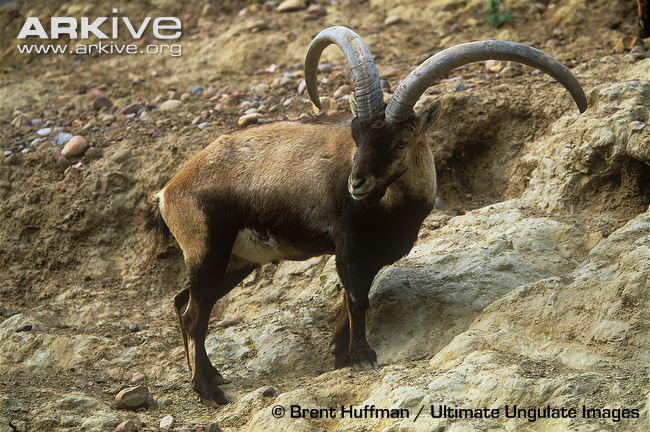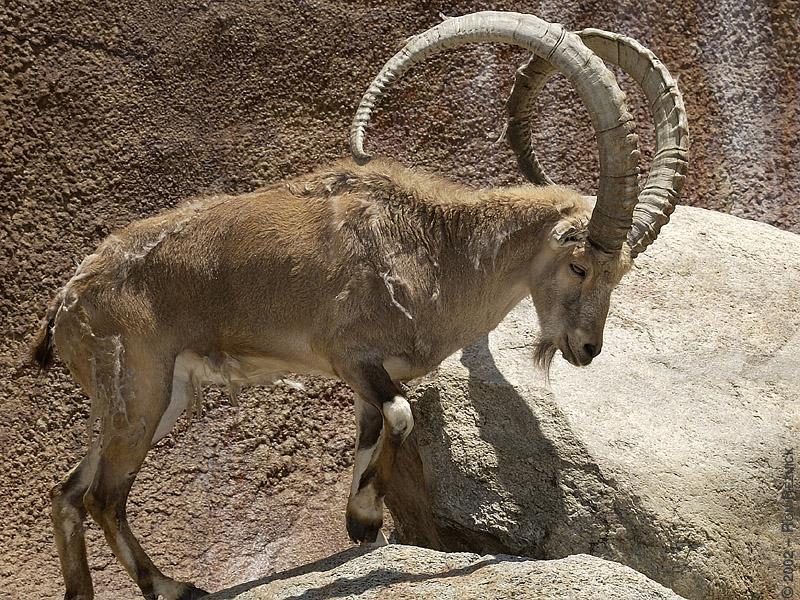The first image is the image on the left, the second image is the image on the right. Analyze the images presented: Is the assertion "A man stands behind his hunting trophy." valid? Answer yes or no. No. The first image is the image on the left, the second image is the image on the right. Evaluate the accuracy of this statement regarding the images: "The left and right image contains the same number of goats with at least one hunter holding its horns.". Is it true? Answer yes or no. No. 